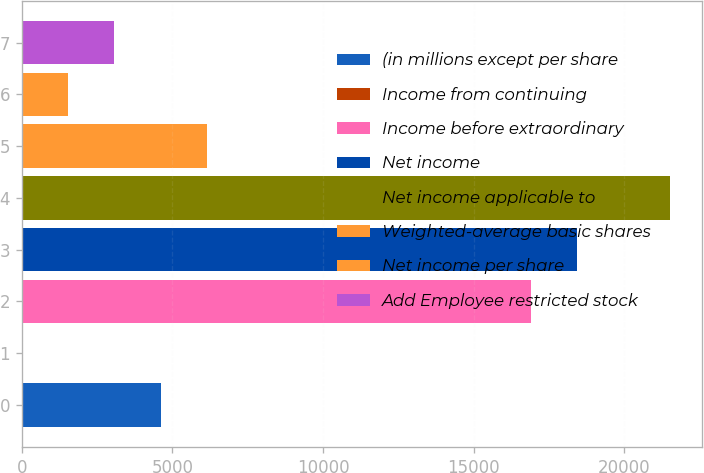Convert chart to OTSL. <chart><loc_0><loc_0><loc_500><loc_500><bar_chart><fcel>(in millions except per share<fcel>Income from continuing<fcel>Income before extraordinary<fcel>Net income<fcel>Net income applicable to<fcel>Weighted-average basic shares<fcel>Net income per share<fcel>Add Employee restricted stock<nl><fcel>4612.66<fcel>4.51<fcel>16901<fcel>18437.1<fcel>21509.2<fcel>6148.71<fcel>1540.56<fcel>3076.61<nl></chart> 